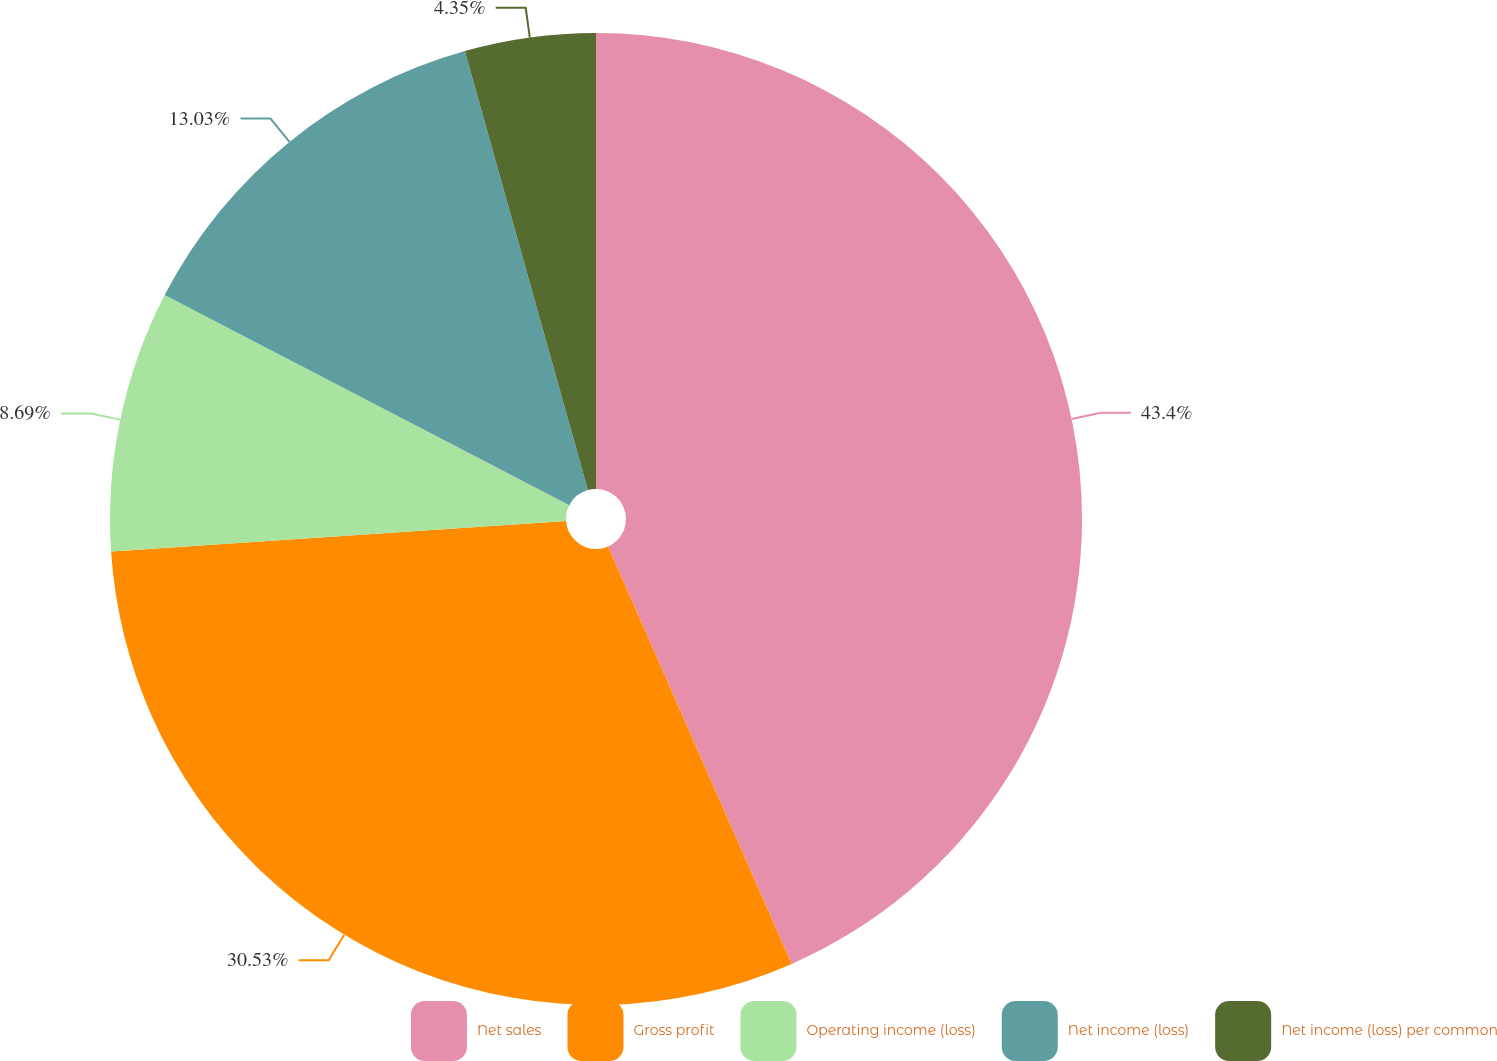Convert chart. <chart><loc_0><loc_0><loc_500><loc_500><pie_chart><fcel>Net sales<fcel>Gross profit<fcel>Operating income (loss)<fcel>Net income (loss)<fcel>Net income (loss) per common<nl><fcel>43.41%<fcel>30.53%<fcel>8.69%<fcel>13.03%<fcel>4.35%<nl></chart> 